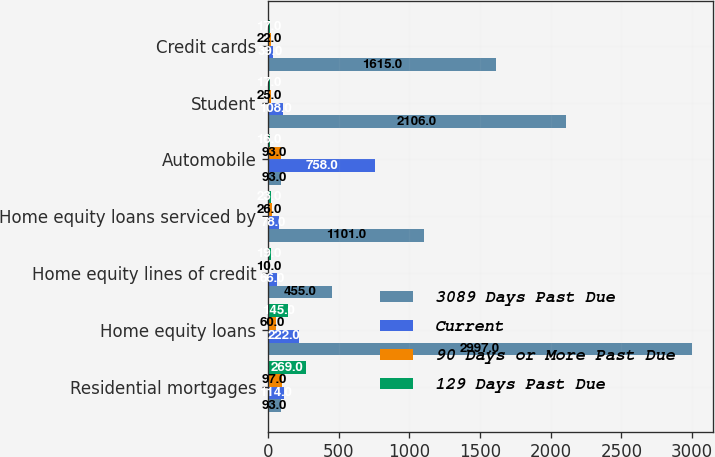Convert chart to OTSL. <chart><loc_0><loc_0><loc_500><loc_500><stacked_bar_chart><ecel><fcel>Residential mortgages<fcel>Home equity loans<fcel>Home equity lines of credit<fcel>Home equity loans serviced by<fcel>Automobile<fcel>Student<fcel>Credit cards<nl><fcel>3089 Days Past Due<fcel>93<fcel>2997<fcel>455<fcel>1101<fcel>93<fcel>2106<fcel>1615<nl><fcel>Current<fcel>114<fcel>222<fcel>66<fcel>78<fcel>758<fcel>108<fcel>39<nl><fcel>90 Days or More Past Due<fcel>97<fcel>60<fcel>10<fcel>26<fcel>93<fcel>25<fcel>22<nl><fcel>129 Days Past Due<fcel>269<fcel>145<fcel>19<fcel>23<fcel>16<fcel>17<fcel>17<nl></chart> 